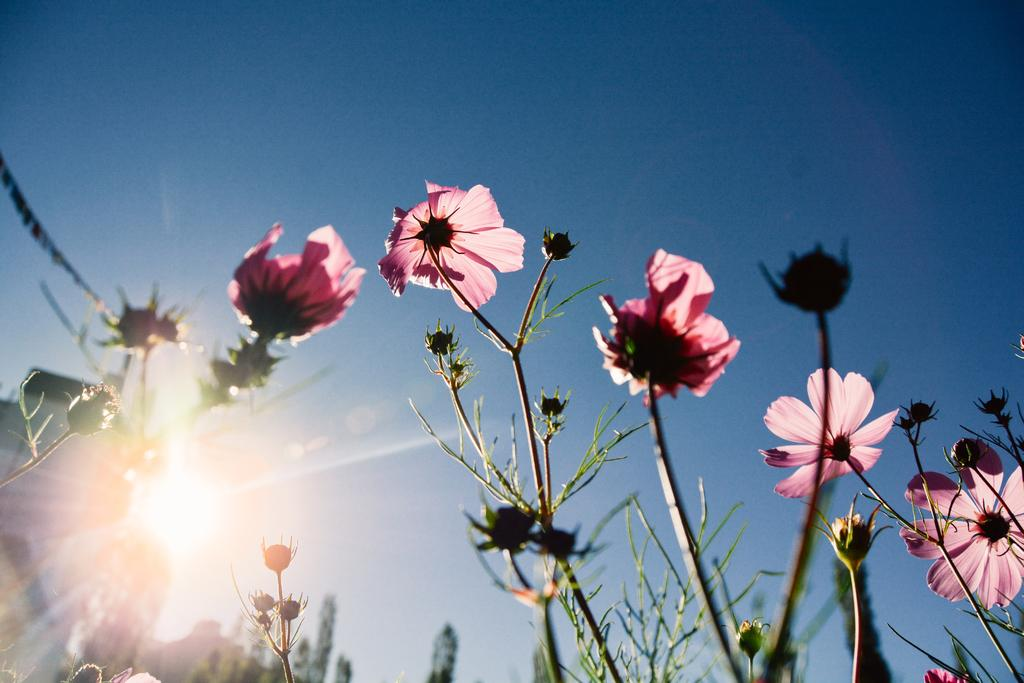What type of plants are present in the image? There are plants with pink flowers in the image. What can be seen in the background of the image? There are trees in the background of the image. What celestial body is visible in the image? The sun is visible in the image. What is the color of the sky in the image? The sky is blue in the image. What type of locket can be seen hanging from the tree in the image? There is no locket present in the image; it only features plants with pink flowers, trees, the sun, and the blue sky. 